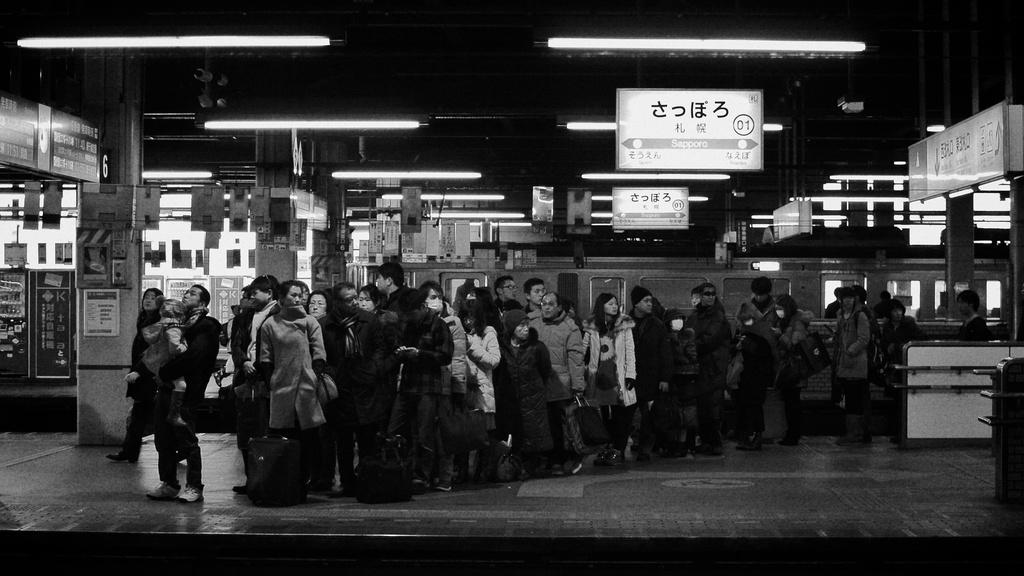How many people are in the image? There is a group of people in the image, but the exact number cannot be determined from the provided facts. What can be seen in the background of the image? There are lights, hoardings, and a train visible in the background of the image. What is the color scheme of the image? The image is in black and white. What type of locket is the person wearing in the image? There is no locket visible in the image. How does the person control the train in the background of the image? There is no indication that the person in the image is controlling the train, and the train is likely not under manual control. 